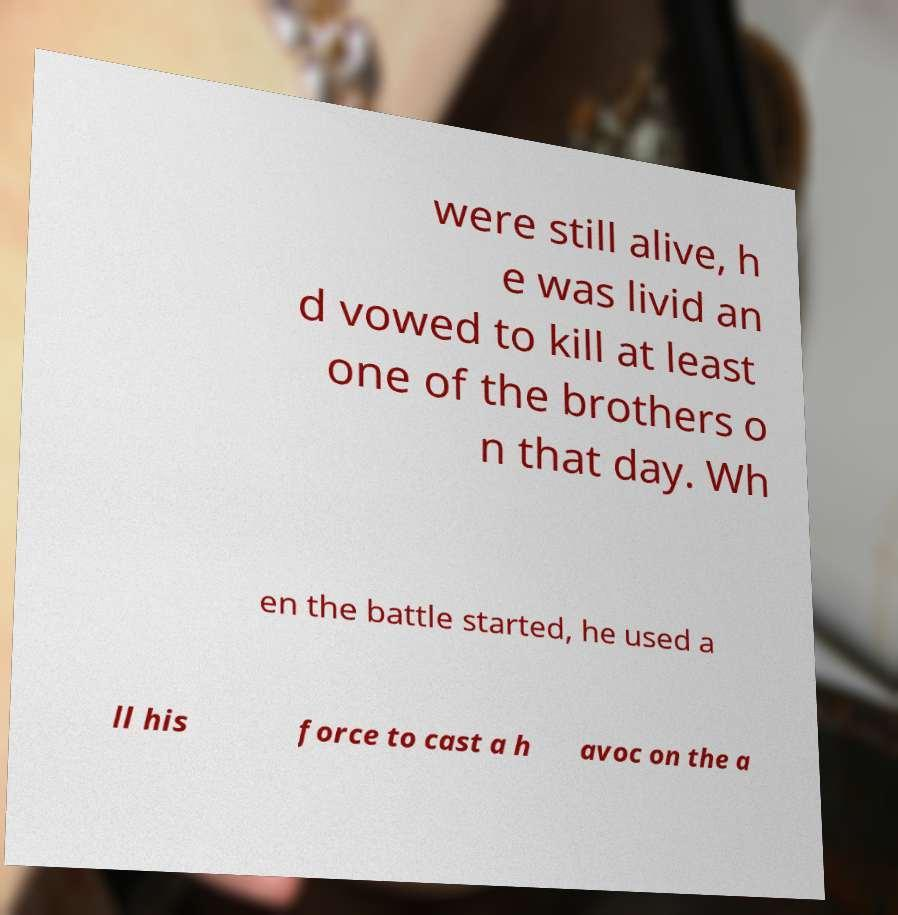Please read and relay the text visible in this image. What does it say? were still alive, h e was livid an d vowed to kill at least one of the brothers o n that day. Wh en the battle started, he used a ll his force to cast a h avoc on the a 